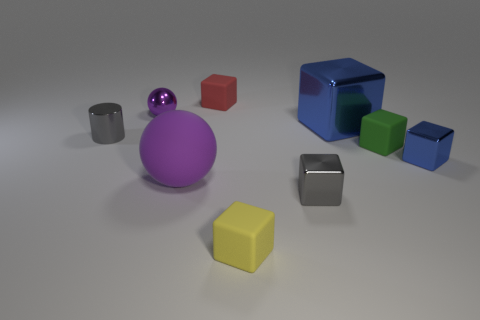Subtract 3 cubes. How many cubes are left? 3 Subtract all tiny gray metallic blocks. How many blocks are left? 5 Subtract all yellow cubes. How many cubes are left? 5 Subtract all red blocks. Subtract all blue cylinders. How many blocks are left? 5 Subtract all blocks. How many objects are left? 3 Add 9 small green cubes. How many small green cubes exist? 10 Subtract 0 brown blocks. How many objects are left? 9 Subtract all cyan matte cubes. Subtract all blue metal blocks. How many objects are left? 7 Add 1 gray things. How many gray things are left? 3 